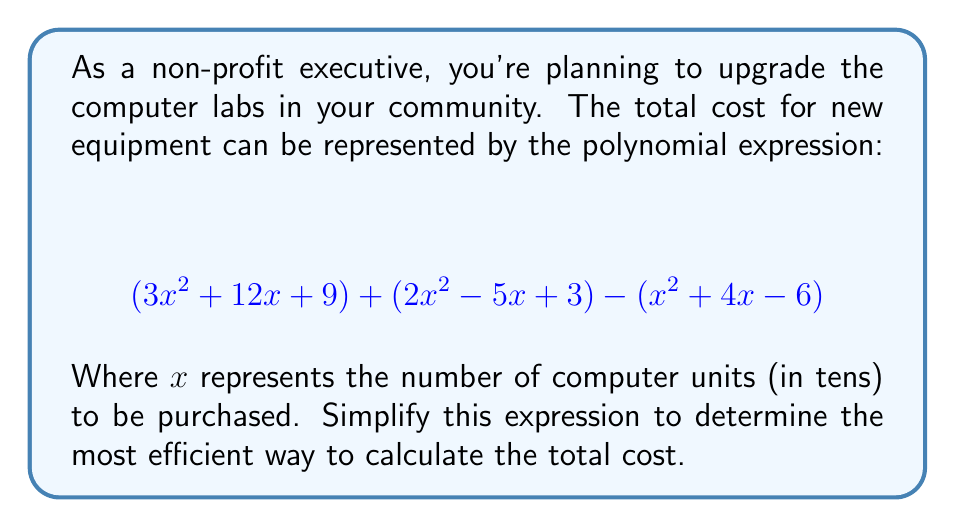Solve this math problem. To simplify this polynomial expression, we need to combine like terms. Let's approach this step-by-step:

1) First, let's identify the like terms in the expression:
   - $x^2$ terms: $3x^2$, $2x^2$, and $-x^2$
   - $x$ terms: $12x$, $-5x$, and $-4x$
   - Constant terms: $9$, $3$, and $6$

2) Now, let's combine these like terms:

   For $x^2$ terms:
   $$3x^2 + 2x^2 - x^2 = 4x^2$$

   For $x$ terms:
   $$12x - 5x - 4x = 3x$$

   For constant terms:
   $$9 + 3 + 6 = 18$$

3) Now we can write our simplified expression:

   $$4x^2 + 3x + 18$$

This simplified form represents the total cost of the computer lab equipment, where $x$ is the number of computer units in tens.
Answer: $$4x^2 + 3x + 18$$ 